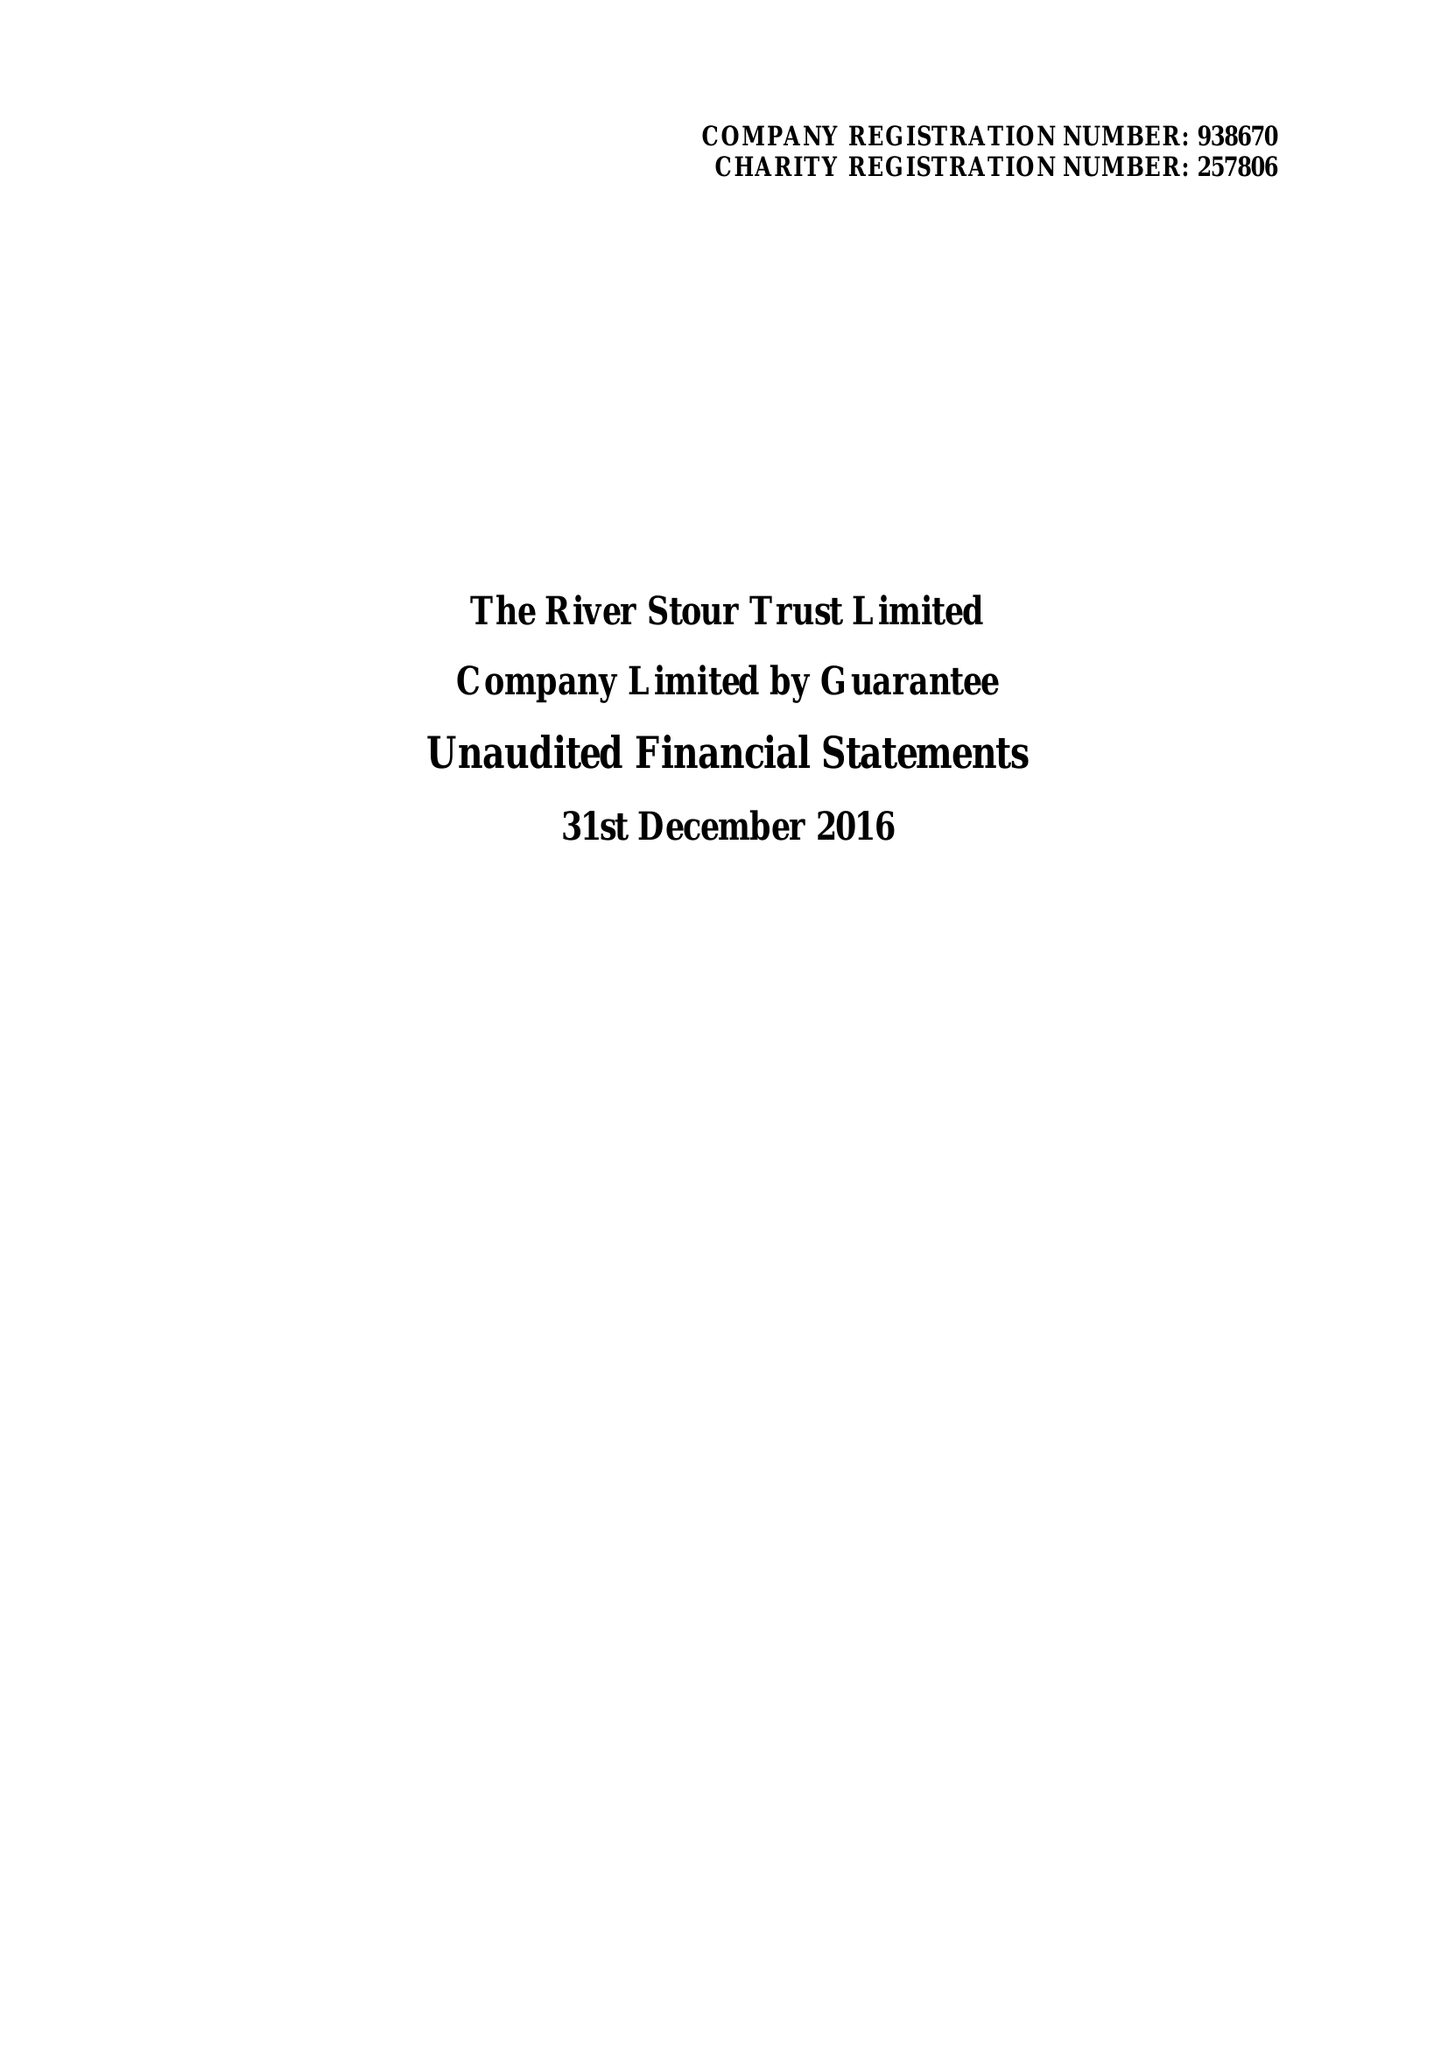What is the value for the report_date?
Answer the question using a single word or phrase. 2016-12-31 